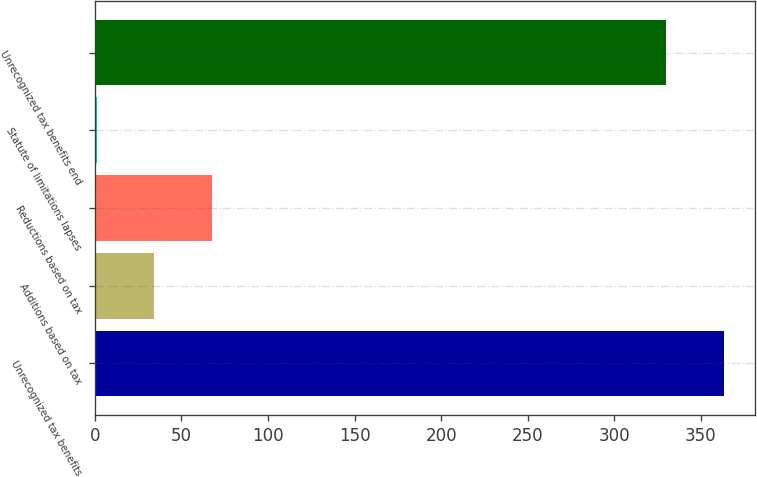<chart> <loc_0><loc_0><loc_500><loc_500><bar_chart><fcel>Unrecognized tax benefits<fcel>Additions based on tax<fcel>Reductions based on tax<fcel>Statute of limitations lapses<fcel>Unrecognized tax benefits end<nl><fcel>363.2<fcel>34.2<fcel>67.4<fcel>1<fcel>330<nl></chart> 